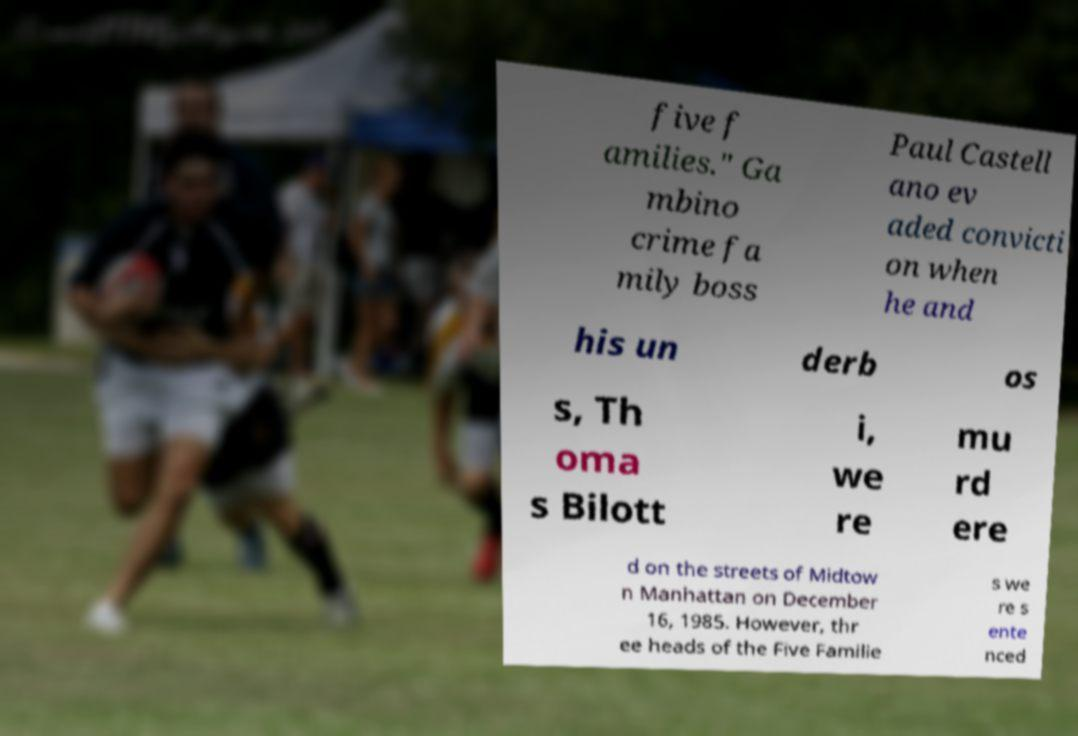Please read and relay the text visible in this image. What does it say? five f amilies." Ga mbino crime fa mily boss Paul Castell ano ev aded convicti on when he and his un derb os s, Th oma s Bilott i, we re mu rd ere d on the streets of Midtow n Manhattan on December 16, 1985. However, thr ee heads of the Five Familie s we re s ente nced 